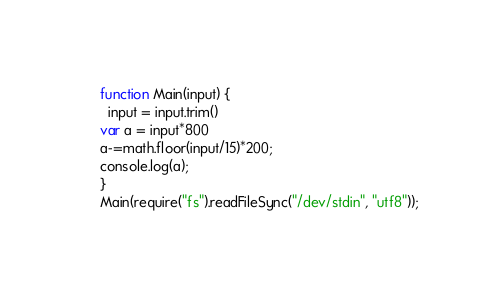Convert code to text. <code><loc_0><loc_0><loc_500><loc_500><_JavaScript_>function Main(input) {
  input = input.trim()
var a = input*800
a-=math.floor(input/15)*200;
console.log(a);
}
Main(require("fs").readFileSync("/dev/stdin", "utf8"));</code> 